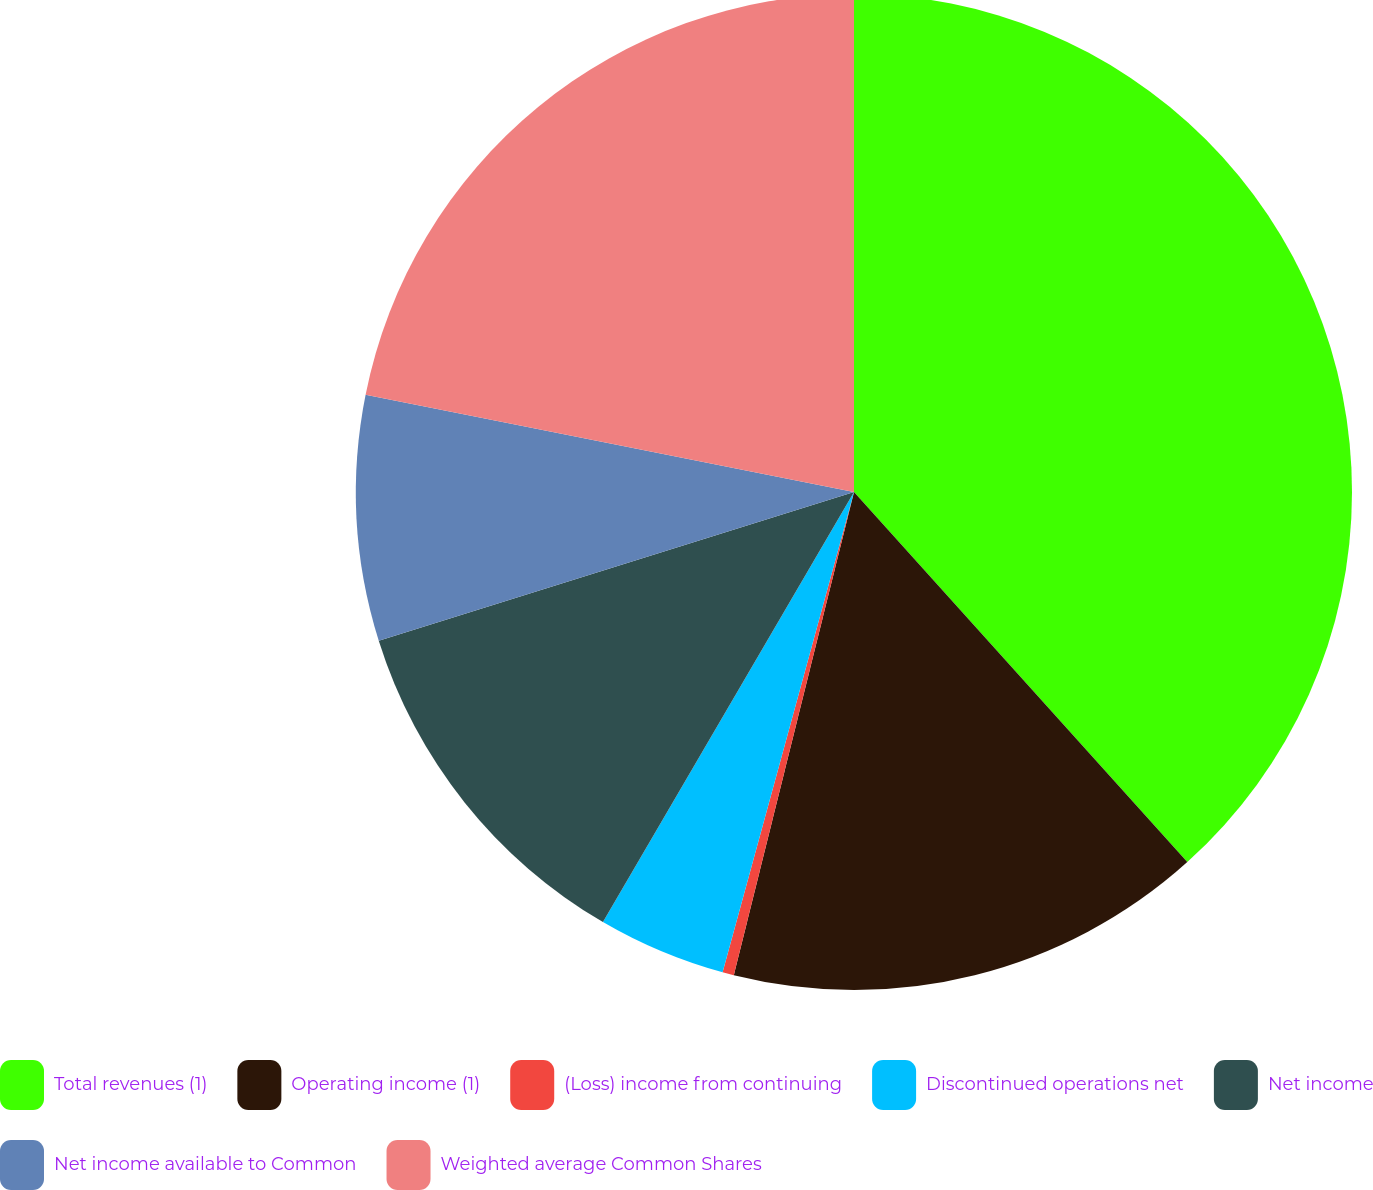<chart> <loc_0><loc_0><loc_500><loc_500><pie_chart><fcel>Total revenues (1)<fcel>Operating income (1)<fcel>(Loss) income from continuing<fcel>Discontinued operations net<fcel>Net income<fcel>Net income available to Common<fcel>Weighted average Common Shares<nl><fcel>38.33%<fcel>15.55%<fcel>0.37%<fcel>4.16%<fcel>11.76%<fcel>7.96%<fcel>21.87%<nl></chart> 